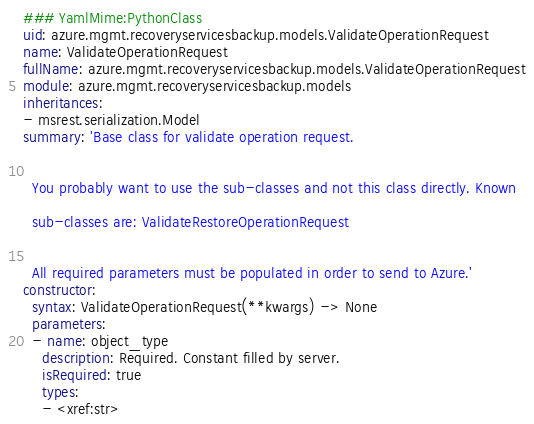<code> <loc_0><loc_0><loc_500><loc_500><_YAML_>### YamlMime:PythonClass
uid: azure.mgmt.recoveryservicesbackup.models.ValidateOperationRequest
name: ValidateOperationRequest
fullName: azure.mgmt.recoveryservicesbackup.models.ValidateOperationRequest
module: azure.mgmt.recoveryservicesbackup.models
inheritances:
- msrest.serialization.Model
summary: 'Base class for validate operation request.


  You probably want to use the sub-classes and not this class directly. Known

  sub-classes are: ValidateRestoreOperationRequest


  All required parameters must be populated in order to send to Azure.'
constructor:
  syntax: ValidateOperationRequest(**kwargs) -> None
  parameters:
  - name: object_type
    description: Required. Constant filled by server.
    isRequired: true
    types:
    - <xref:str>
</code> 